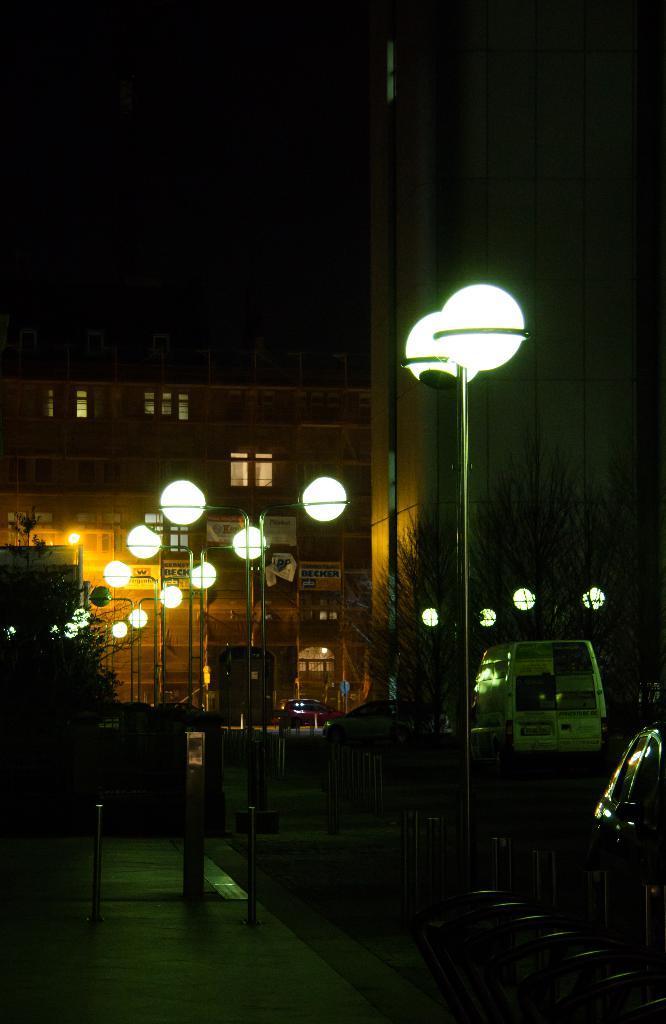Could you give a brief overview of what you see in this image? In this picture there are some lamp post on the road side and some cars are parked. In the background there are is a brown color building. 